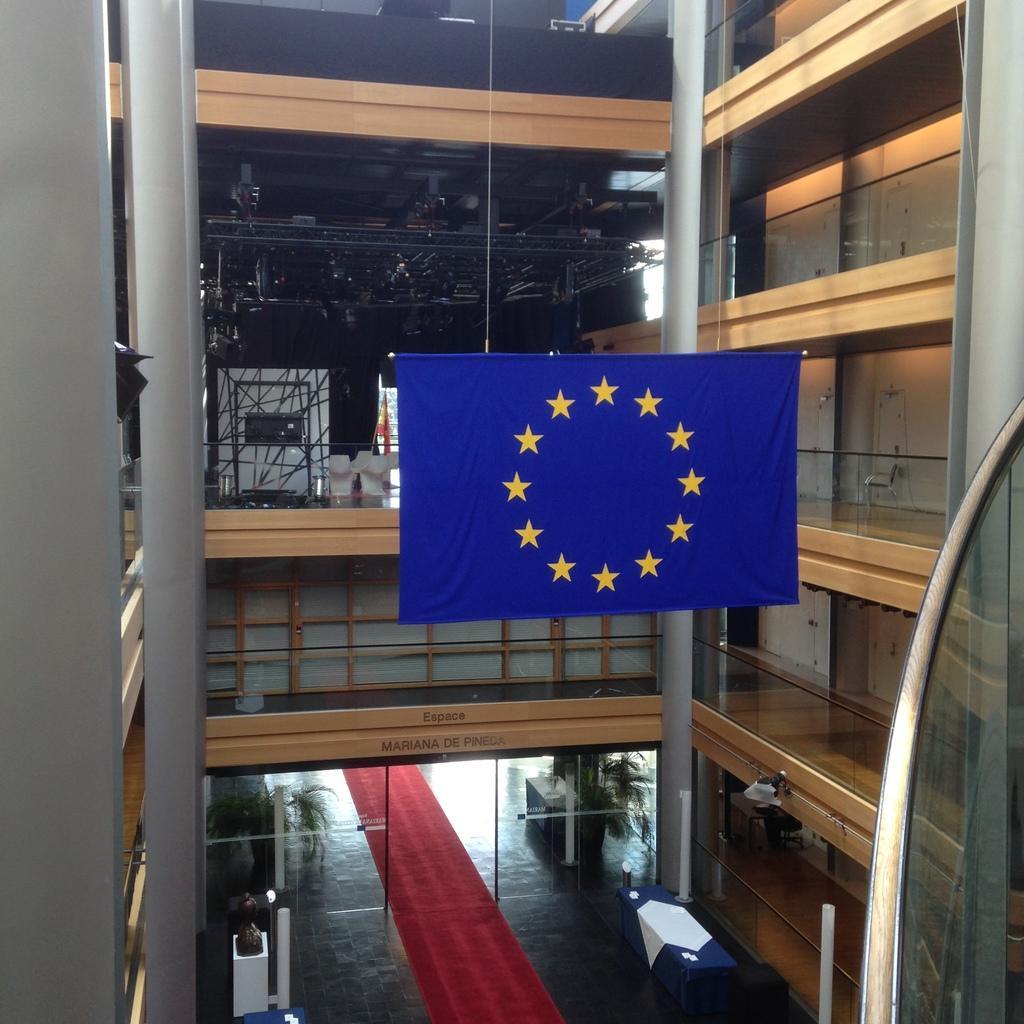How would you summarize this image in a sentence or two? It is a five star hotel and it has many floors and in between the restaurant, there is a flag hangs down and there is a red carpet on the floor. 